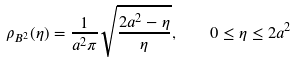Convert formula to latex. <formula><loc_0><loc_0><loc_500><loc_500>\rho _ { B ^ { 2 } } ( \eta ) = \frac { 1 } { a ^ { 2 } \pi } \sqrt { \frac { 2 a ^ { 2 } - \eta } { \eta } } , \quad 0 \leq \eta \leq 2 a ^ { 2 }</formula> 